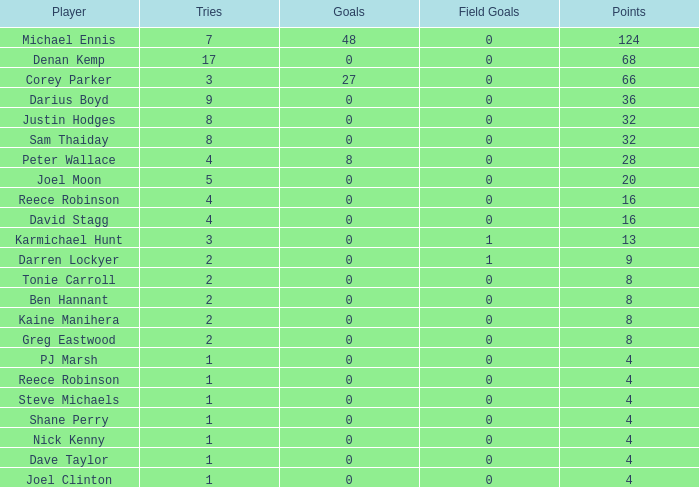Write the full table. {'header': ['Player', 'Tries', 'Goals', 'Field Goals', 'Points'], 'rows': [['Michael Ennis', '7', '48', '0', '124'], ['Denan Kemp', '17', '0', '0', '68'], ['Corey Parker', '3', '27', '0', '66'], ['Darius Boyd', '9', '0', '0', '36'], ['Justin Hodges', '8', '0', '0', '32'], ['Sam Thaiday', '8', '0', '0', '32'], ['Peter Wallace', '4', '8', '0', '28'], ['Joel Moon', '5', '0', '0', '20'], ['Reece Robinson', '4', '0', '0', '16'], ['David Stagg', '4', '0', '0', '16'], ['Karmichael Hunt', '3', '0', '1', '13'], ['Darren Lockyer', '2', '0', '1', '9'], ['Tonie Carroll', '2', '0', '0', '8'], ['Ben Hannant', '2', '0', '0', '8'], ['Kaine Manihera', '2', '0', '0', '8'], ['Greg Eastwood', '2', '0', '0', '8'], ['PJ Marsh', '1', '0', '0', '4'], ['Reece Robinson', '1', '0', '0', '4'], ['Steve Michaels', '1', '0', '0', '4'], ['Shane Perry', '1', '0', '0', '4'], ['Nick Kenny', '1', '0', '0', '4'], ['Dave Taylor', '1', '0', '0', '4'], ['Joel Clinton', '1', '0', '0', '4']]} How many goals did the player with less than 4 points have? 0.0. 